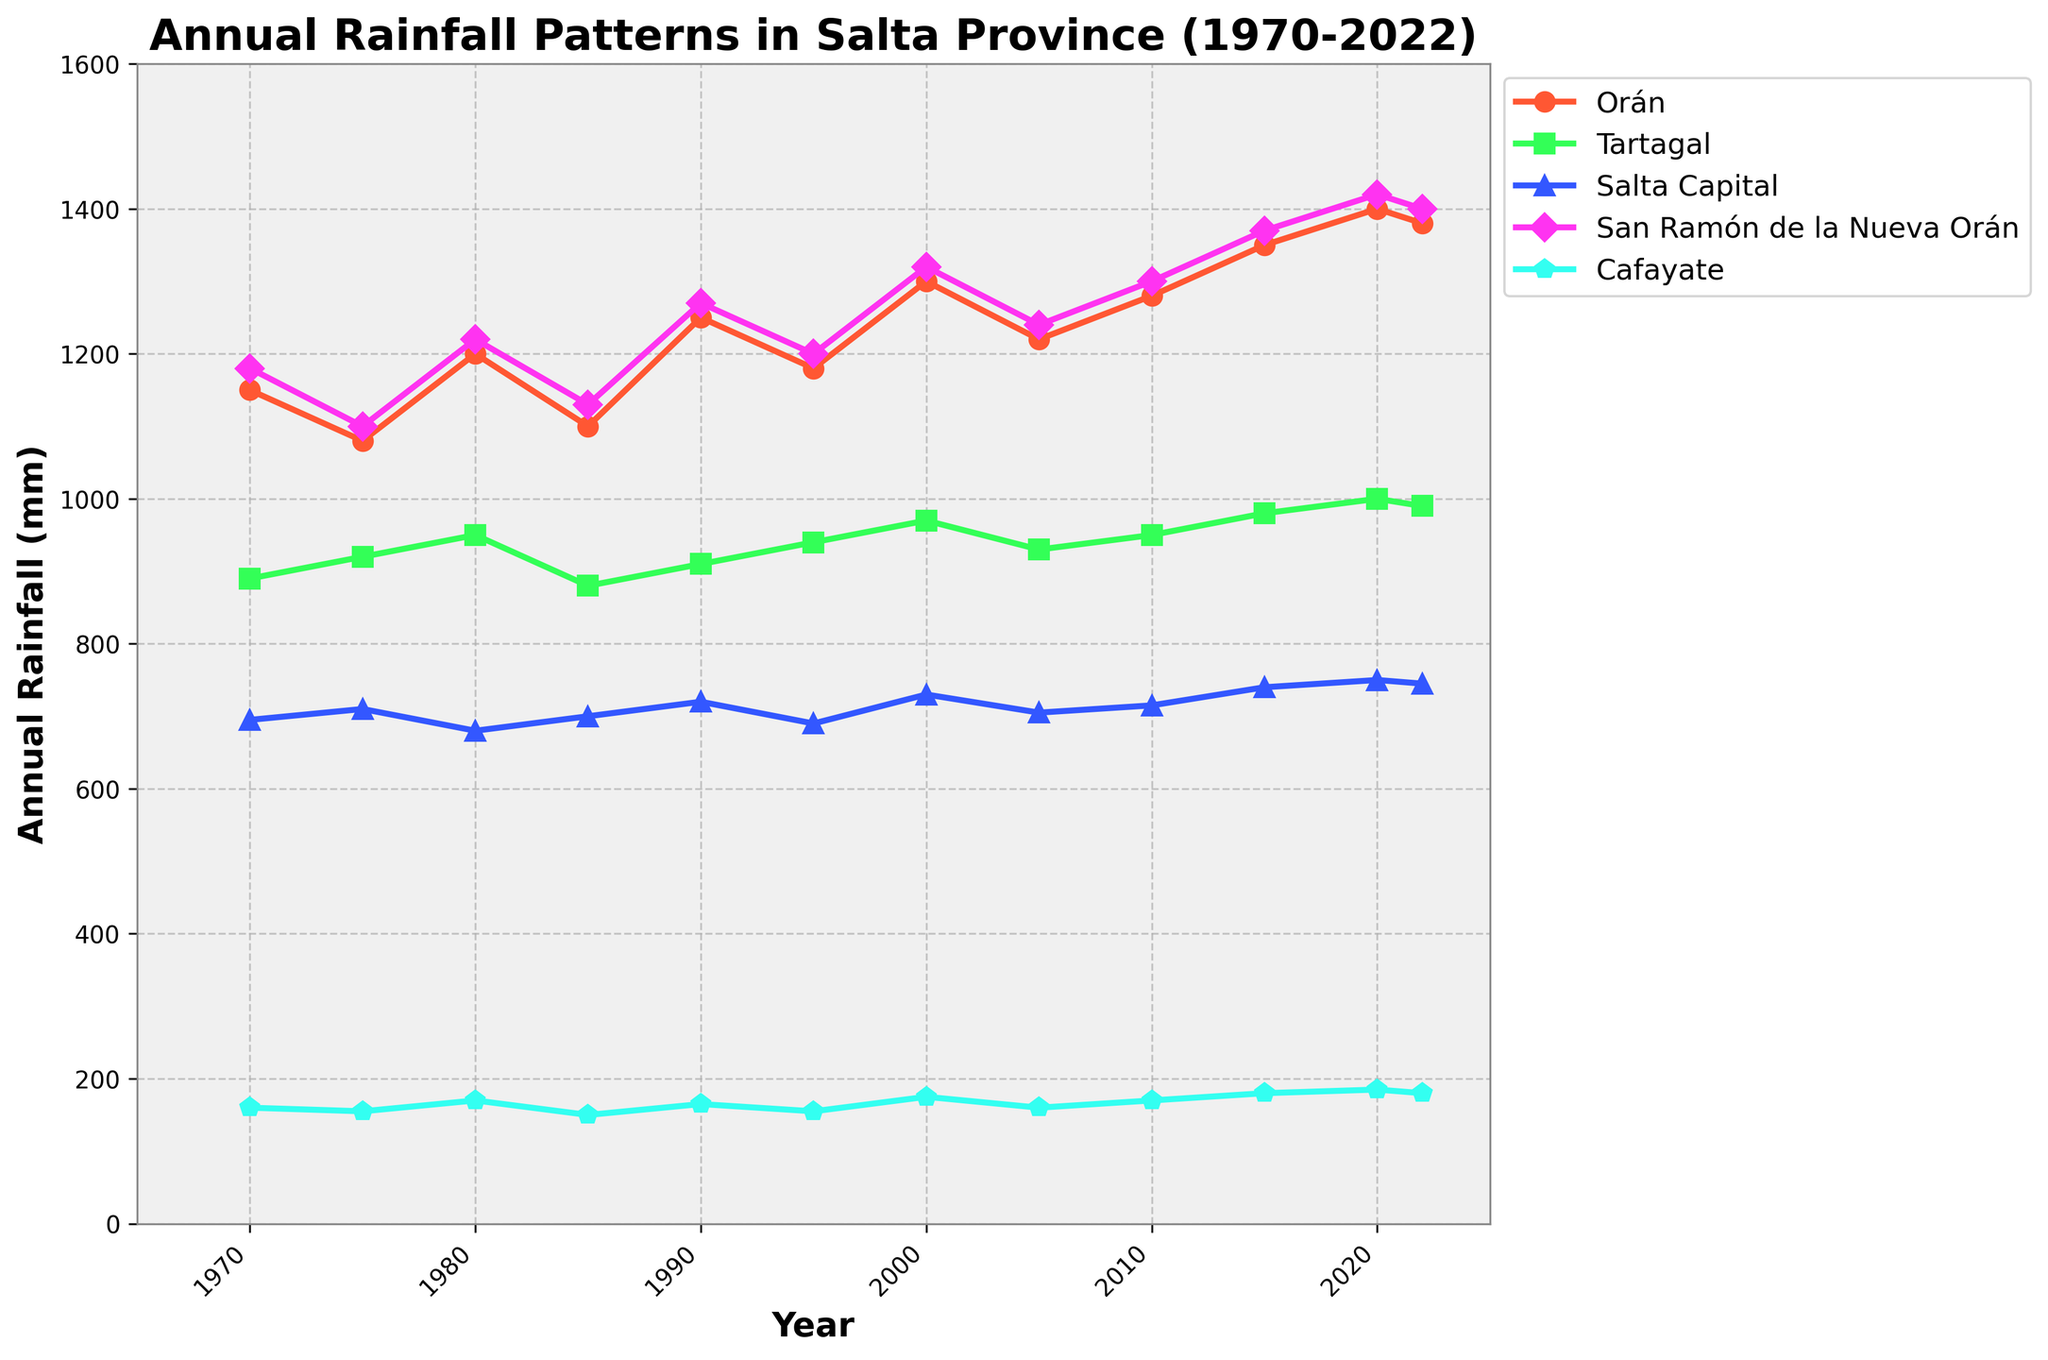What is the average annual rainfall in Orán for the years provided? Add up all the annual rainfall values for Orán and divide by the total number of years ([1150 + 1080 + 1200 + 1100 + 1250 + 1180 + 1300 + 1220 + 1280 + 1350 + 1400 + 1380] / 12).
Answer: 1232.5 mm Which city had the highest annual rainfall in 2020? Look at the data points for the year 2020 and compare the values for each city. The highest value is for Orán with 1400 mm.
Answer: Orán Compare the annual rainfall trend in Orán and Cafayate from 1970 to 2022. Which city shows a more significant increase? Calculate the difference in annual rainfall between 1970 and 2022 for both cities (Orán: 1380 - 1150 = 230 mm, Cafayate: 180 - 160 = 20 mm). Orán shows a more significant increase.
Answer: Orán Which city has the least variability in annual rainfall over the years? Observe the fluctuations in the values for each city over the years. Cafayate exhibits the least variability because its values are relatively consistent around the 160-185 mm range.
Answer: Cafayate If you average the annual rainfall for all cities in 1980, what is the result? Sum the values for 1980 [1200 + 950 + 680 + 1220 + 170] and divide by the number of cities (5). Average = (1200 + 950 + 680 + 1220 + 170) / 5.
Answer: 844 mm In which year did Tartagal experience the highest annual rainfall, and what was the value? Check the values for Tartagal across all years and identify the highest value, which is 1000 mm in 2020.
Answer: 2020, 1000 mm Between 2015 and 2020, which city had the most consistent annual rainfall pattern? Compare the variations in annual rainfall values for each city between 2015 and 2020. San Ramón de la Nueva Orán shows minimal variation (1350 mm to 1420 mm).
Answer: San Ramón de la Nueva Orán What is the trend in annual rainfall for Salta Capital from 1970 to 2022? Observe the changes in annual rainfall values for Salta Capital from start to end. It shows a generally increasing trend from 695 mm in 1970 to 745 mm in 2022.
Answer: Increasing Is there any year where all cities experienced an increase in annual rainfall compared to the previous year? Look at the data and compare year-over-year changes for all cities simultaneously. Between 2010 and 2015, all cities show an increase in values.
Answer: Between 2010 and 2015 How does the annual rainfall in Orán for 2000 compare to San Ramón de la Nueva Orán? Compare the values for the year 2000 for Orán (1300 mm) and San Ramón de la Nueva Orán (1320 mm). San Ramón de la Nueva Orán has slightly higher rainfall.
Answer: San Ramón de la Nueva Orán 